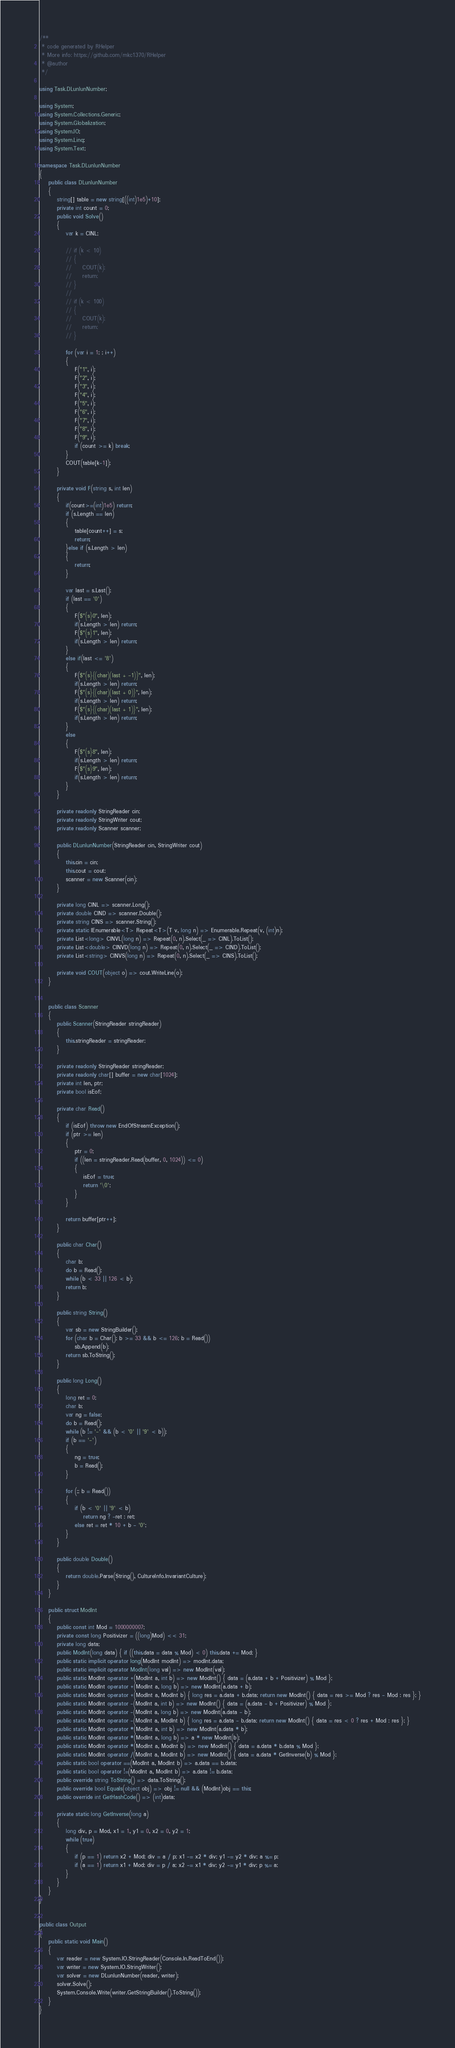<code> <loc_0><loc_0><loc_500><loc_500><_C#_>/**
 * code generated by RHelper
 * More info: https://github.com/mkc1370/RHelper
 * @author 
 */

using Task.DLunlunNumber;

using System;
using System.Collections.Generic;
using System.Globalization;
using System.IO;
using System.Linq;
using System.Text;

namespace Task.DLunlunNumber
{
    public class DLunlunNumber
    {
        string[] table = new string[((int)1e5)+10];
        private int count = 0;
        public void Solve()
        {
            var k = CINL;

            // if (k < 10)
            // {
            //     COUT(k);
            //     return;
            // }
            //
            // if (k < 100)
            // {
            //     COUT(k);
            //     return;
            // }

            for (var i = 1; ; i++)
            {
                F("1", i);
                F("2", i);
                F("3", i);
                F("4", i);
                F("5", i);
                F("6", i);
                F("7", i);
                F("8", i);
                F("9", i);
                if (count >= k) break;
            }
            COUT(table[k-1]);
        }

        private void F(string s, int len)
        {
            if(count>=(int)1e5) return;
            if (s.Length == len)
            {
                table[count++] = s;
                return;
            }else if (s.Length > len)
            {
                return;
            }

            var last = s.Last();
            if (last == '0')
            {
                F($"{s}0", len);
                if(s.Length > len) return;
                F($"{s}1", len);
                if(s.Length > len) return;
            }
            else if(last <= '8')
            {
                F($"{s}{(char)(last + -1)}", len);
                if(s.Length > len) return;
                F($"{s}{(char)(last + 0)}", len);
                if(s.Length > len) return;
                F($"{s}{(char)(last + 1)}", len);
                if(s.Length > len) return;
            }
            else
            {
                F($"{s}8", len);
                if(s.Length > len) return;
                F($"{s}9", len);
                if(s.Length > len) return;
            }
        }
        
        private readonly StringReader cin;
        private readonly StringWriter cout;
        private readonly Scanner scanner;

        public DLunlunNumber(StringReader cin, StringWriter cout)
        {
            this.cin = cin;
            this.cout = cout;
            scanner = new Scanner(cin);
        }

        private long CINL => scanner.Long();
        private double CIND => scanner.Double();
        private string CINS => scanner.String();
        private static IEnumerable<T> Repeat<T>(T v, long n) => Enumerable.Repeat(v, (int)n);
        private List<long> CINVL(long n) => Repeat(0, n).Select(_ => CINL).ToList();
        private List<double> CINVD(long n) => Repeat(0, n).Select(_ => CIND).ToList();
        private List<string> CINVS(long n) => Repeat(0, n).Select(_ => CINS).ToList();

        private void COUT(object o) => cout.WriteLine(o);
    }


    public class Scanner
    {
        public Scanner(StringReader stringReader)
        {
            this.stringReader = stringReader;
        }

        private readonly StringReader stringReader;
        private readonly char[] buffer = new char[1024];
        private int len, ptr;
        private bool isEof;

        private char Read()
        {
            if (isEof) throw new EndOfStreamException();
            if (ptr >= len)
            {
                ptr = 0;
                if ((len = stringReader.Read(buffer, 0, 1024)) <= 0)
                {
                    isEof = true;
                    return '\0';
                }
            }

            return buffer[ptr++];
        }

        public char Char()
        {
            char b;
            do b = Read();
            while (b < 33 || 126 < b);
            return b;
        }

        public string String()
        {
            var sb = new StringBuilder();
            for (char b = Char(); b >= 33 && b <= 126; b = Read())
                sb.Append(b);
            return sb.ToString();
        }

        public long Long()
        {
            long ret = 0;
            char b;
            var ng = false;
            do b = Read();
            while (b != '-' && (b < '0' || '9' < b));
            if (b == '-')
            {
                ng = true;
                b = Read();
            }

            for (;; b = Read())
            {
                if (b < '0' || '9' < b)
                    return ng ? -ret : ret;
                else ret = ret * 10 + b - '0';
            }
        }

        public double Double()
        {
            return double.Parse(String(), CultureInfo.InvariantCulture);
        }
    }

    public struct ModInt
    {
        public const int Mod = 1000000007;
        private const long Positivizer = ((long)Mod) << 31;
        private long data;
        public ModInt(long data) { if ((this.data = data % Mod) < 0) this.data += Mod; }
        public static implicit operator long(ModInt modInt) => modInt.data;
        public static implicit operator ModInt(long val) => new ModInt(val);
        public static ModInt operator +(ModInt a, int b) => new ModInt() { data = (a.data + b + Positivizer) % Mod };
        public static ModInt operator +(ModInt a, long b) => new ModInt(a.data + b);
        public static ModInt operator +(ModInt a, ModInt b) { long res = a.data + b.data; return new ModInt() { data = res >= Mod ? res - Mod : res }; }
        public static ModInt operator -(ModInt a, int b) => new ModInt() { data = (a.data - b + Positivizer) % Mod };
        public static ModInt operator -(ModInt a, long b) => new ModInt(a.data - b);
        public static ModInt operator -(ModInt a, ModInt b) { long res = a.data - b.data; return new ModInt() { data = res < 0 ? res + Mod : res }; }
        public static ModInt operator *(ModInt a, int b) => new ModInt(a.data * b);
        public static ModInt operator *(ModInt a, long b) => a * new ModInt(b);
        public static ModInt operator *(ModInt a, ModInt b) => new ModInt() { data = a.data * b.data % Mod };
        public static ModInt operator /(ModInt a, ModInt b) => new ModInt() { data = a.data * GetInverse(b) % Mod };
        public static bool operator ==(ModInt a, ModInt b) => a.data == b.data;
        public static bool operator !=(ModInt a, ModInt b) => a.data != b.data;
        public override string ToString() => data.ToString();
        public override bool Equals(object obj) => obj != null && (ModInt)obj == this;
        public override int GetHashCode() => (int)data;

        private static long GetInverse(long a)
        {
            long div, p = Mod, x1 = 1, y1 = 0, x2 = 0, y2 = 1;
            while (true)
            {
                if (p == 1) return x2 + Mod; div = a / p; x1 -= x2 * div; y1 -= y2 * div; a %= p;
                if (a == 1) return x1 + Mod; div = p / a; x2 -= x1 * div; y2 -= y1 * div; p %= a;
            }
        }
    }
}


public class Output
{
	public static void Main()
	{
		var reader = new System.IO.StringReader(Console.In.ReadToEnd());
		var writer = new System.IO.StringWriter();
		var solver = new DLunlunNumber(reader, writer);
		solver.Solve();
		System.Console.Write(writer.GetStringBuilder().ToString());
	}
}
</code> 